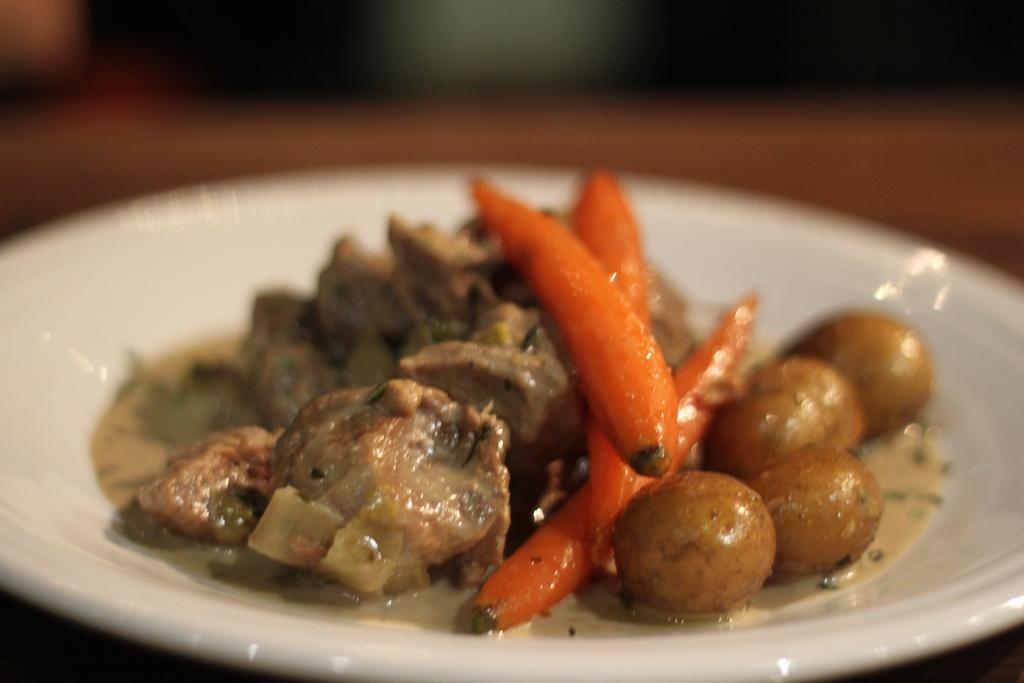Please provide a concise description of this image. In this image we can see some food items on the plate, and the background is blurred. 